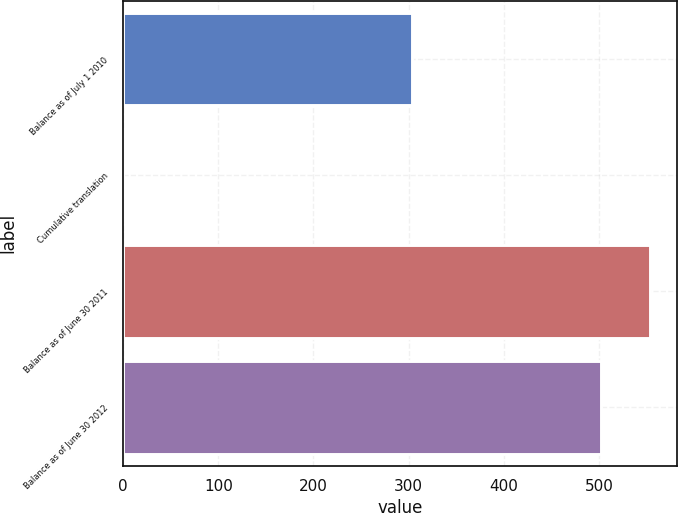<chart> <loc_0><loc_0><loc_500><loc_500><bar_chart><fcel>Balance as of July 1 2010<fcel>Cumulative translation<fcel>Balance as of June 30 2011<fcel>Balance as of June 30 2012<nl><fcel>303.1<fcel>0.1<fcel>554.07<fcel>502.4<nl></chart> 